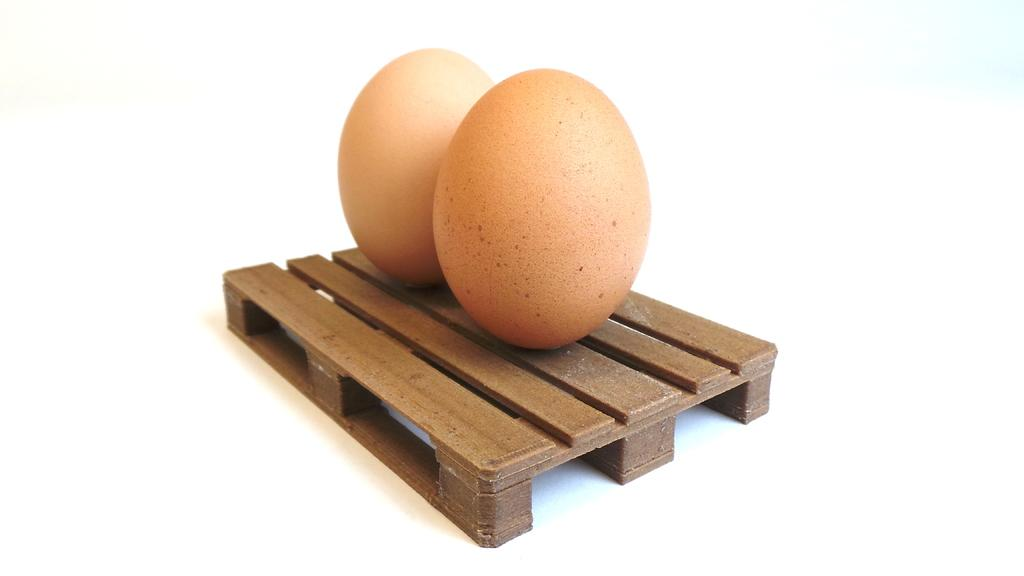What objects are present in the image? There are two eggs in the image. Where are the eggs placed? The eggs are on a scale model table. What color is the background of the image? The background of the image is white. Can you tell me how many pigs are fighting over the cherry in the image? There are no pigs or cherries present in the image. 